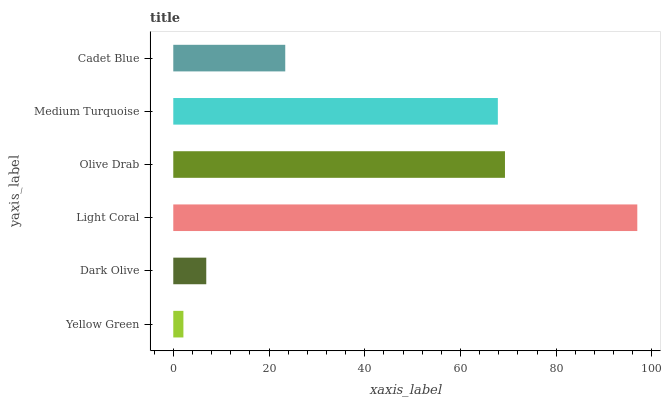Is Yellow Green the minimum?
Answer yes or no. Yes. Is Light Coral the maximum?
Answer yes or no. Yes. Is Dark Olive the minimum?
Answer yes or no. No. Is Dark Olive the maximum?
Answer yes or no. No. Is Dark Olive greater than Yellow Green?
Answer yes or no. Yes. Is Yellow Green less than Dark Olive?
Answer yes or no. Yes. Is Yellow Green greater than Dark Olive?
Answer yes or no. No. Is Dark Olive less than Yellow Green?
Answer yes or no. No. Is Medium Turquoise the high median?
Answer yes or no. Yes. Is Cadet Blue the low median?
Answer yes or no. Yes. Is Cadet Blue the high median?
Answer yes or no. No. Is Dark Olive the low median?
Answer yes or no. No. 